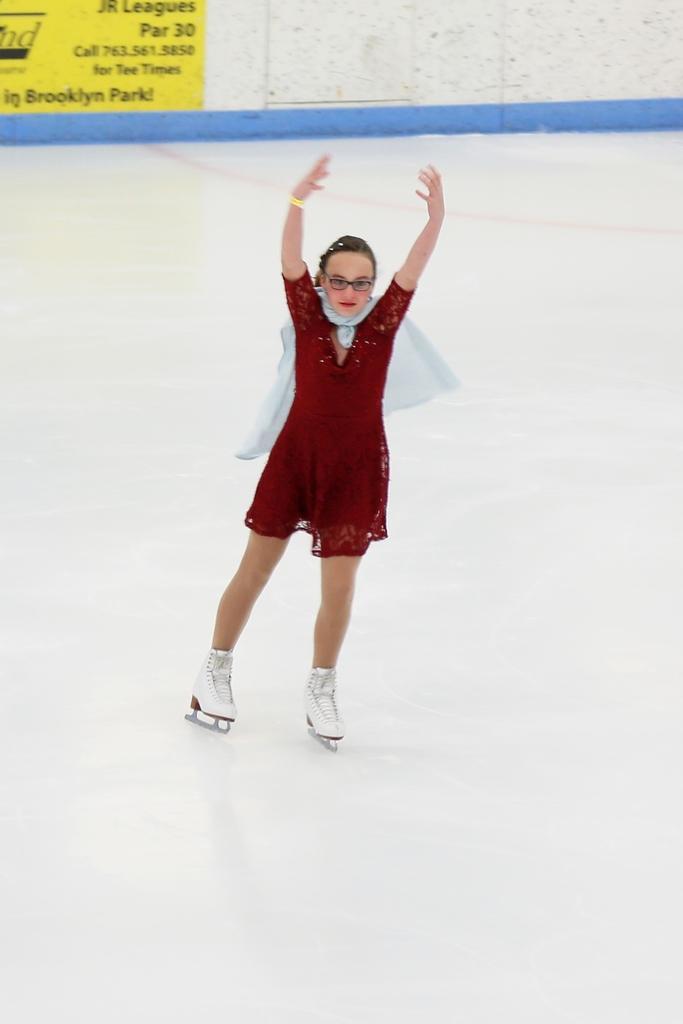Can you describe this image briefly? In this image there is a woman ice skating, behind the woman there is a banner on the wall. 